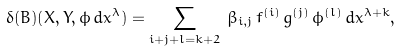<formula> <loc_0><loc_0><loc_500><loc_500>\delta ( B ) ( X , Y , \phi \, d x ^ { \lambda } ) = \sum _ { i + j + l = k + 2 } \, \beta _ { i , j } \, f ^ { ( i ) } \, g ^ { ( j ) } \, \phi ^ { ( l ) } \, d x ^ { \lambda + k } ,</formula> 